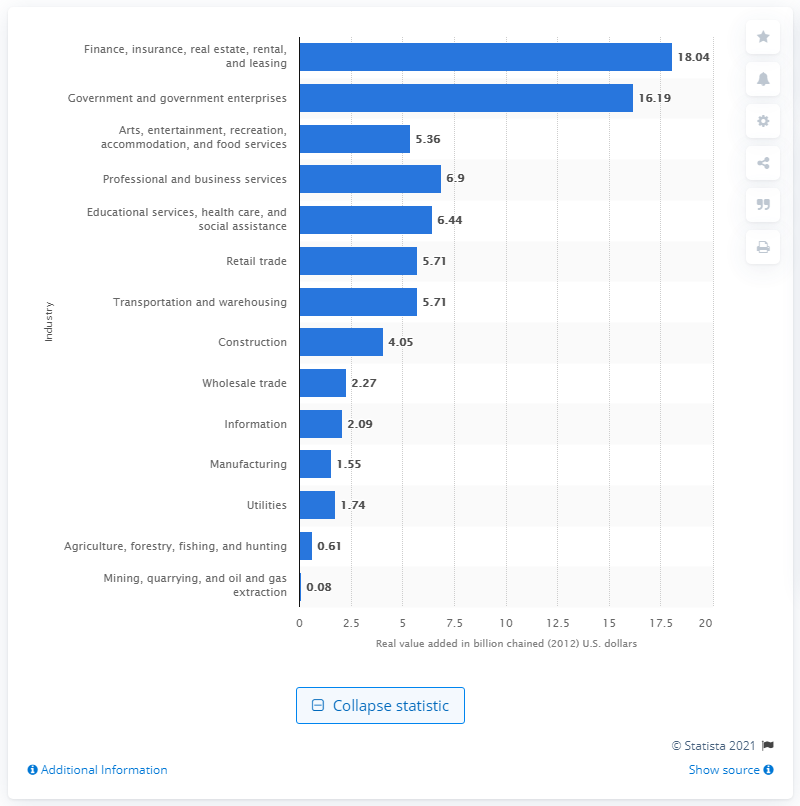Specify some key components in this picture. In 2020, the finance, insurance, real estate, rental, and leasing industry contributed $18.04 billion to Hawaii's Gross Domestic Product. 